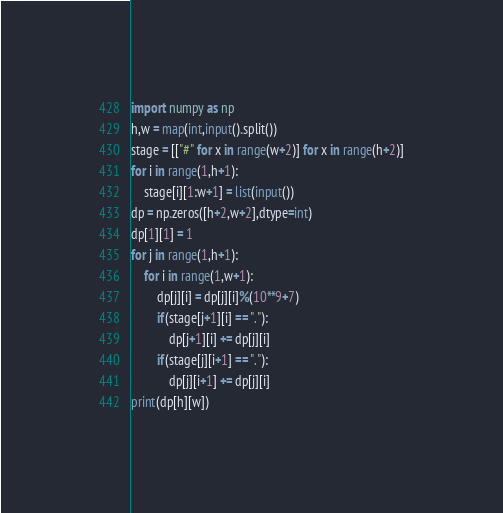Convert code to text. <code><loc_0><loc_0><loc_500><loc_500><_Python_>import numpy as np
h,w = map(int,input().split())
stage = [["#" for x in range(w+2)] for x in range(h+2)]
for i in range(1,h+1):
    stage[i][1:w+1] = list(input())
dp = np.zeros([h+2,w+2],dtype=int)
dp[1][1] = 1
for j in range(1,h+1):
    for i in range(1,w+1):
        dp[j][i] = dp[j][i]%(10**9+7)
        if(stage[j+1][i] == "."):
            dp[j+1][i] += dp[j][i]
        if(stage[j][i+1] == "."):
            dp[j][i+1] += dp[j][i]
print(dp[h][w])
</code> 